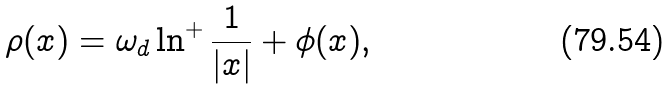Convert formula to latex. <formula><loc_0><loc_0><loc_500><loc_500>\rho ( x ) = \omega _ { d } \ln ^ { + } \frac { 1 } { | x | } + \phi ( x ) ,</formula> 